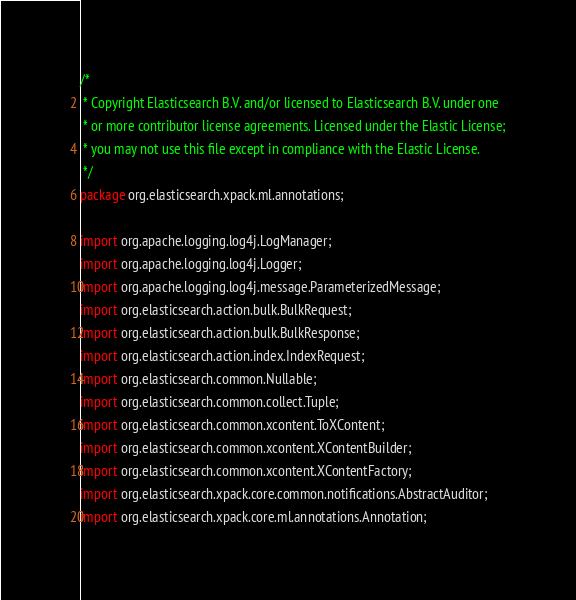<code> <loc_0><loc_0><loc_500><loc_500><_Java_>/*
 * Copyright Elasticsearch B.V. and/or licensed to Elasticsearch B.V. under one
 * or more contributor license agreements. Licensed under the Elastic License;
 * you may not use this file except in compliance with the Elastic License.
 */
package org.elasticsearch.xpack.ml.annotations;

import org.apache.logging.log4j.LogManager;
import org.apache.logging.log4j.Logger;
import org.apache.logging.log4j.message.ParameterizedMessage;
import org.elasticsearch.action.bulk.BulkRequest;
import org.elasticsearch.action.bulk.BulkResponse;
import org.elasticsearch.action.index.IndexRequest;
import org.elasticsearch.common.Nullable;
import org.elasticsearch.common.collect.Tuple;
import org.elasticsearch.common.xcontent.ToXContent;
import org.elasticsearch.common.xcontent.XContentBuilder;
import org.elasticsearch.common.xcontent.XContentFactory;
import org.elasticsearch.xpack.core.common.notifications.AbstractAuditor;
import org.elasticsearch.xpack.core.ml.annotations.Annotation;</code> 